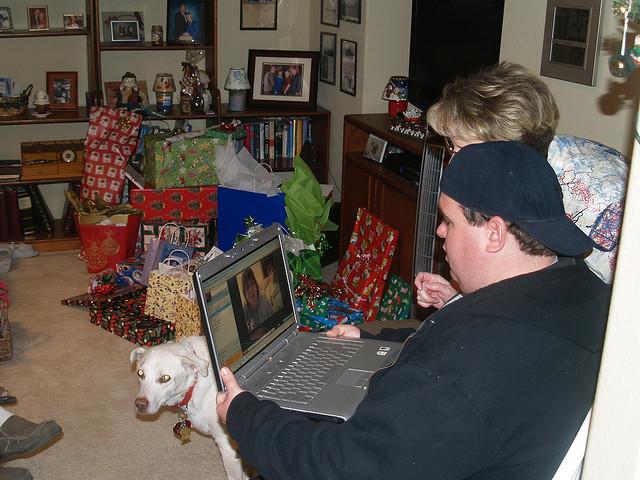What gender is the person next to the dog?
Short answer required. Male. Who is carrying a red bag?
Answer briefly. No one. What type of program are they using on the laptop?
Answer briefly. Skype. What color is the dog's collar?
Quick response, please. Red. What are the dogs waiting for?
Keep it brief. Food. What holiday is this?
Answer briefly. Christmas. Is this photo humane?
Be succinct. Yes. 